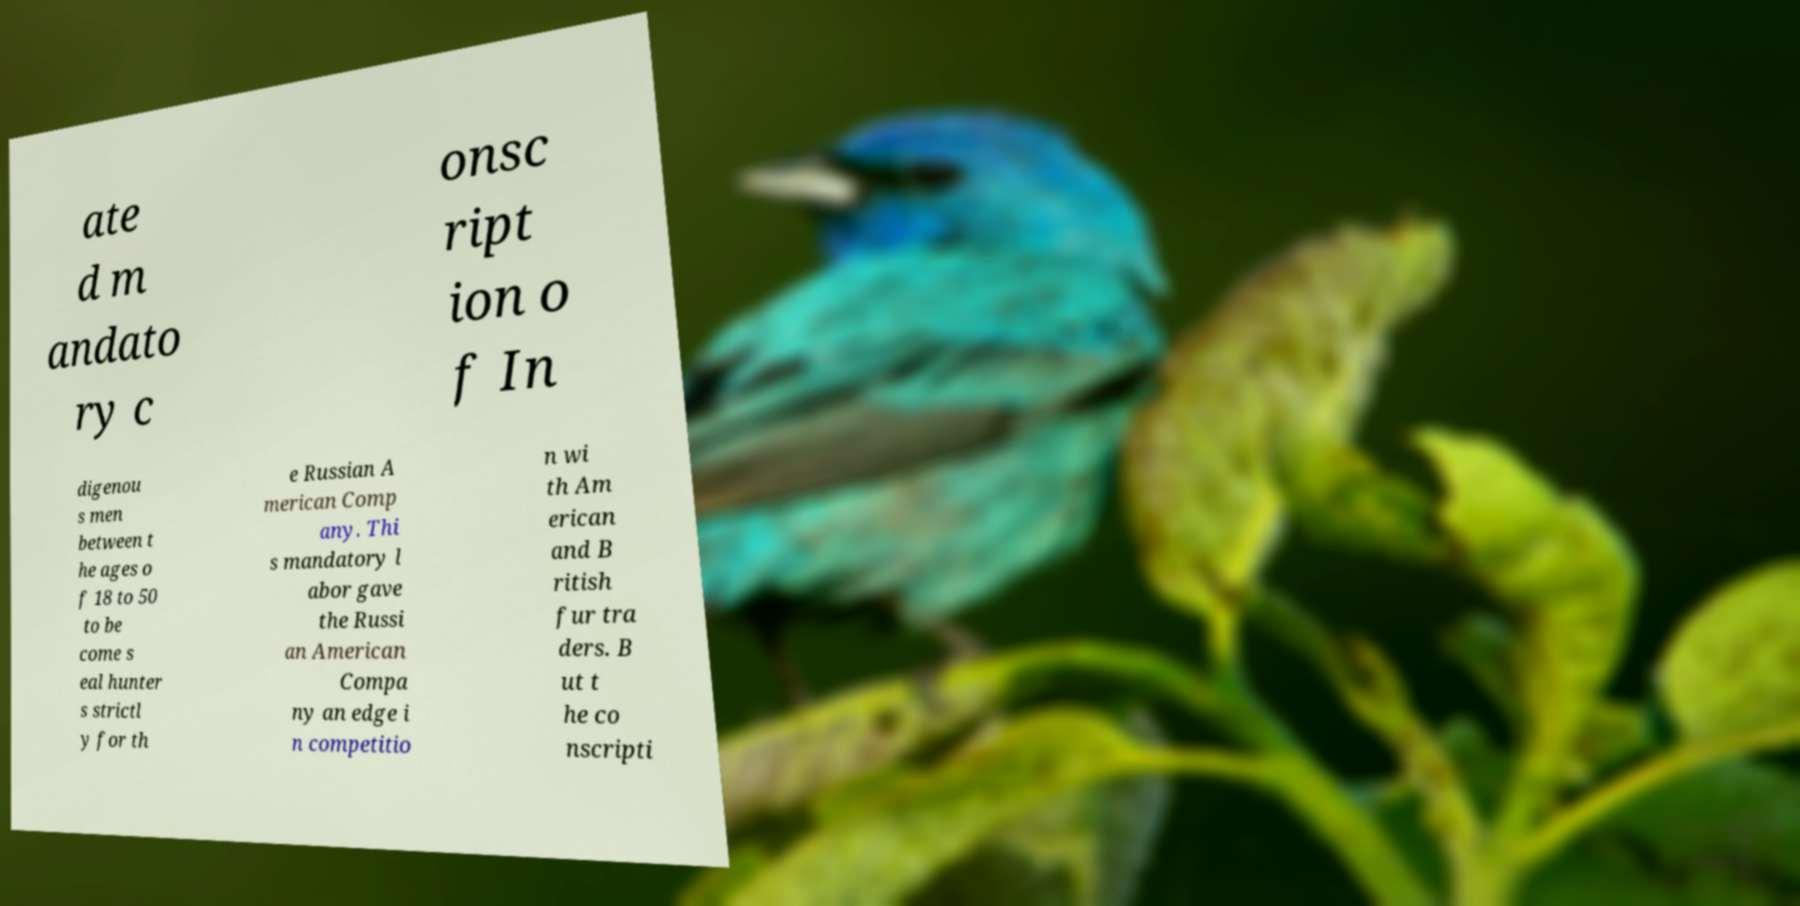Please read and relay the text visible in this image. What does it say? ate d m andato ry c onsc ript ion o f In digenou s men between t he ages o f 18 to 50 to be come s eal hunter s strictl y for th e Russian A merican Comp any. Thi s mandatory l abor gave the Russi an American Compa ny an edge i n competitio n wi th Am erican and B ritish fur tra ders. B ut t he co nscripti 